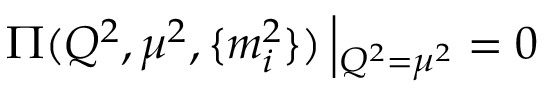Convert formula to latex. <formula><loc_0><loc_0><loc_500><loc_500>\Pi ( Q ^ { 2 } , \mu ^ { 2 } , \{ m _ { i } ^ { 2 } \} ) \left | _ { Q ^ { 2 } = \mu ^ { 2 } } = 0</formula> 